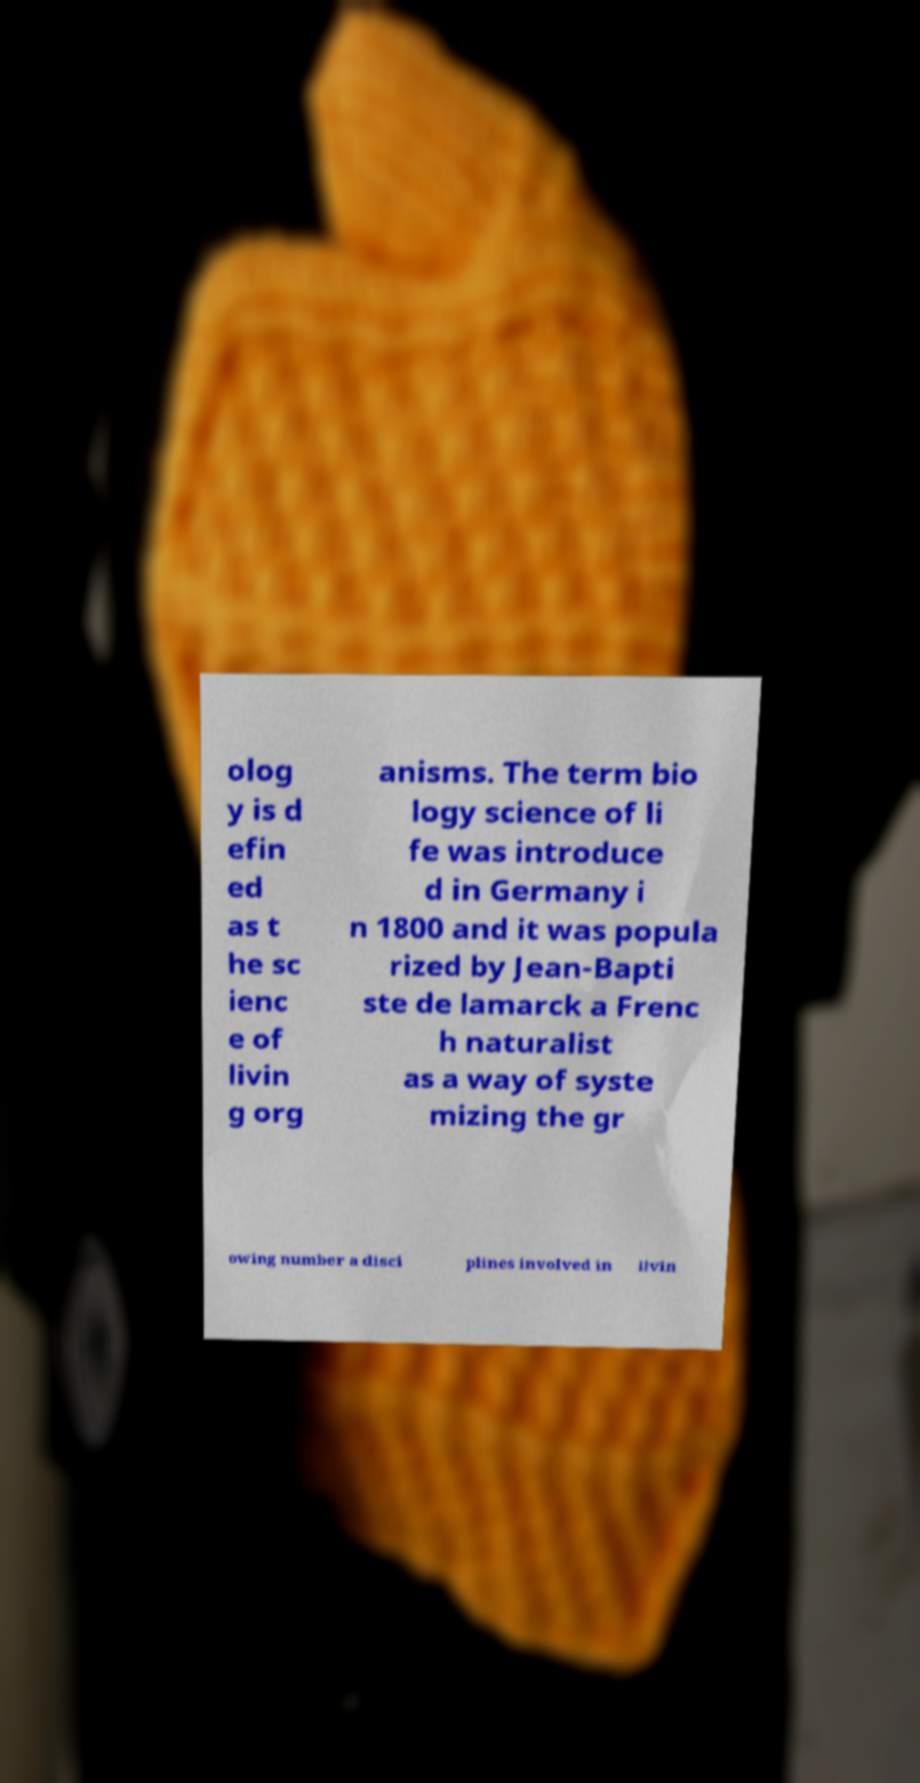Can you accurately transcribe the text from the provided image for me? olog y is d efin ed as t he sc ienc e of livin g org anisms. The term bio logy science of li fe was introduce d in Germany i n 1800 and it was popula rized by Jean-Bapti ste de lamarck a Frenc h naturalist as a way of syste mizing the gr owing number a disci plines involved in livin 